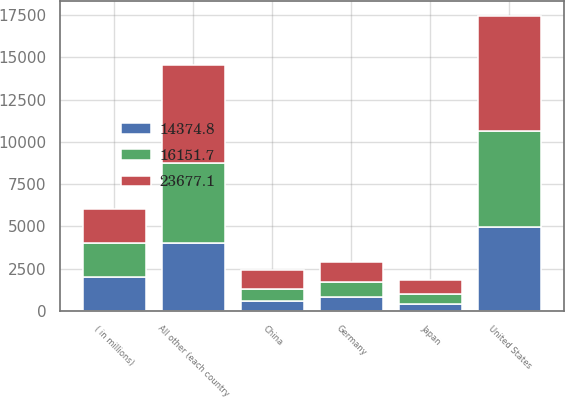Convert chart to OTSL. <chart><loc_0><loc_0><loc_500><loc_500><stacked_bar_chart><ecel><fcel>( in millions)<fcel>United States<fcel>Germany<fcel>China<fcel>Japan<fcel>All other (each country<nl><fcel>23677.1<fcel>2011<fcel>6787.8<fcel>1189<fcel>1133.2<fcel>809.4<fcel>5788.3<nl><fcel>16151.7<fcel>2010<fcel>5703.3<fcel>928.9<fcel>748.7<fcel>603<fcel>4773.4<nl><fcel>14374.8<fcel>2009<fcel>4963.9<fcel>802<fcel>561.9<fcel>410.3<fcel>3999.8<nl></chart> 